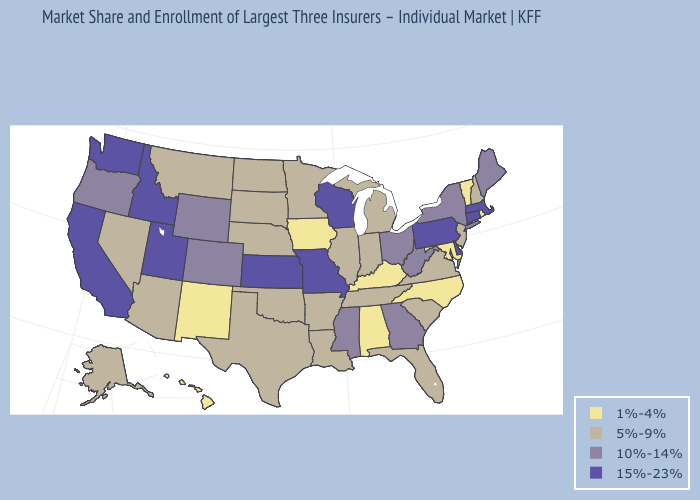Name the states that have a value in the range 1%-4%?
Concise answer only. Alabama, Hawaii, Iowa, Kentucky, Maryland, New Mexico, North Carolina, Rhode Island, Vermont. Does Indiana have a lower value than Wyoming?
Answer briefly. Yes. Name the states that have a value in the range 10%-14%?
Answer briefly. Colorado, Georgia, Maine, Mississippi, New York, Ohio, Oregon, West Virginia, Wyoming. How many symbols are there in the legend?
Write a very short answer. 4. What is the value of West Virginia?
Write a very short answer. 10%-14%. Does the map have missing data?
Quick response, please. No. Does the first symbol in the legend represent the smallest category?
Concise answer only. Yes. What is the value of Nevada?
Quick response, please. 5%-9%. What is the lowest value in states that border Maine?
Keep it brief. 5%-9%. Name the states that have a value in the range 1%-4%?
Keep it brief. Alabama, Hawaii, Iowa, Kentucky, Maryland, New Mexico, North Carolina, Rhode Island, Vermont. What is the highest value in the MidWest ?
Give a very brief answer. 15%-23%. What is the highest value in the USA?
Be succinct. 15%-23%. Does Pennsylvania have the lowest value in the USA?
Short answer required. No. What is the value of Virginia?
Give a very brief answer. 5%-9%. Which states hav the highest value in the West?
Concise answer only. California, Idaho, Utah, Washington. 